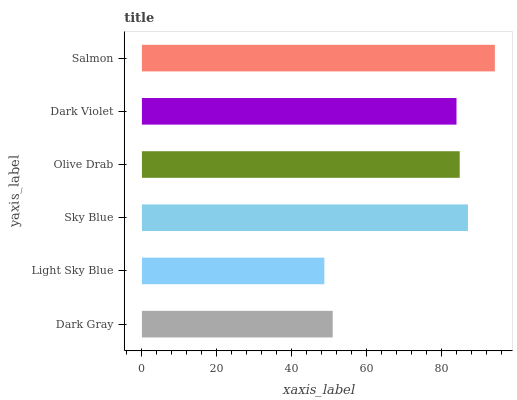Is Light Sky Blue the minimum?
Answer yes or no. Yes. Is Salmon the maximum?
Answer yes or no. Yes. Is Sky Blue the minimum?
Answer yes or no. No. Is Sky Blue the maximum?
Answer yes or no. No. Is Sky Blue greater than Light Sky Blue?
Answer yes or no. Yes. Is Light Sky Blue less than Sky Blue?
Answer yes or no. Yes. Is Light Sky Blue greater than Sky Blue?
Answer yes or no. No. Is Sky Blue less than Light Sky Blue?
Answer yes or no. No. Is Olive Drab the high median?
Answer yes or no. Yes. Is Dark Violet the low median?
Answer yes or no. Yes. Is Light Sky Blue the high median?
Answer yes or no. No. Is Salmon the low median?
Answer yes or no. No. 